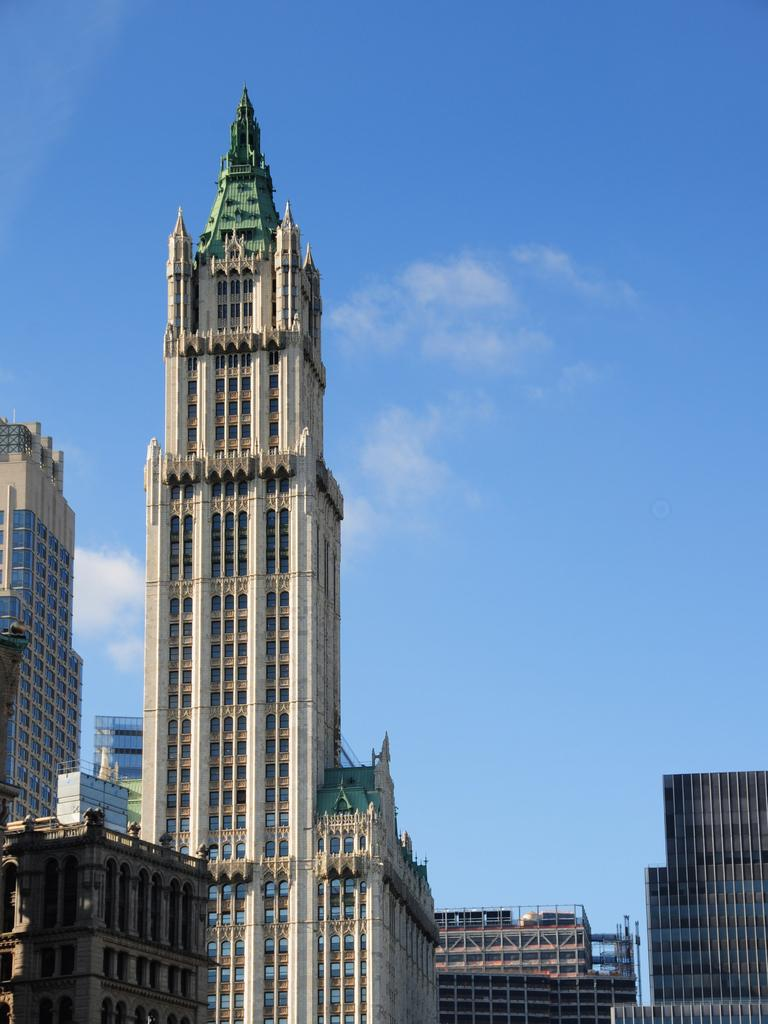What type of structures are visible in the image? There are many buildings with windows in the image. What can be seen in the background of the image? The sky is visible in the background of the image. What is the condition of the sky in the image? Clouds are present in the sky. What historical event is depicted in the image? There is no historical event depicted in the image. 